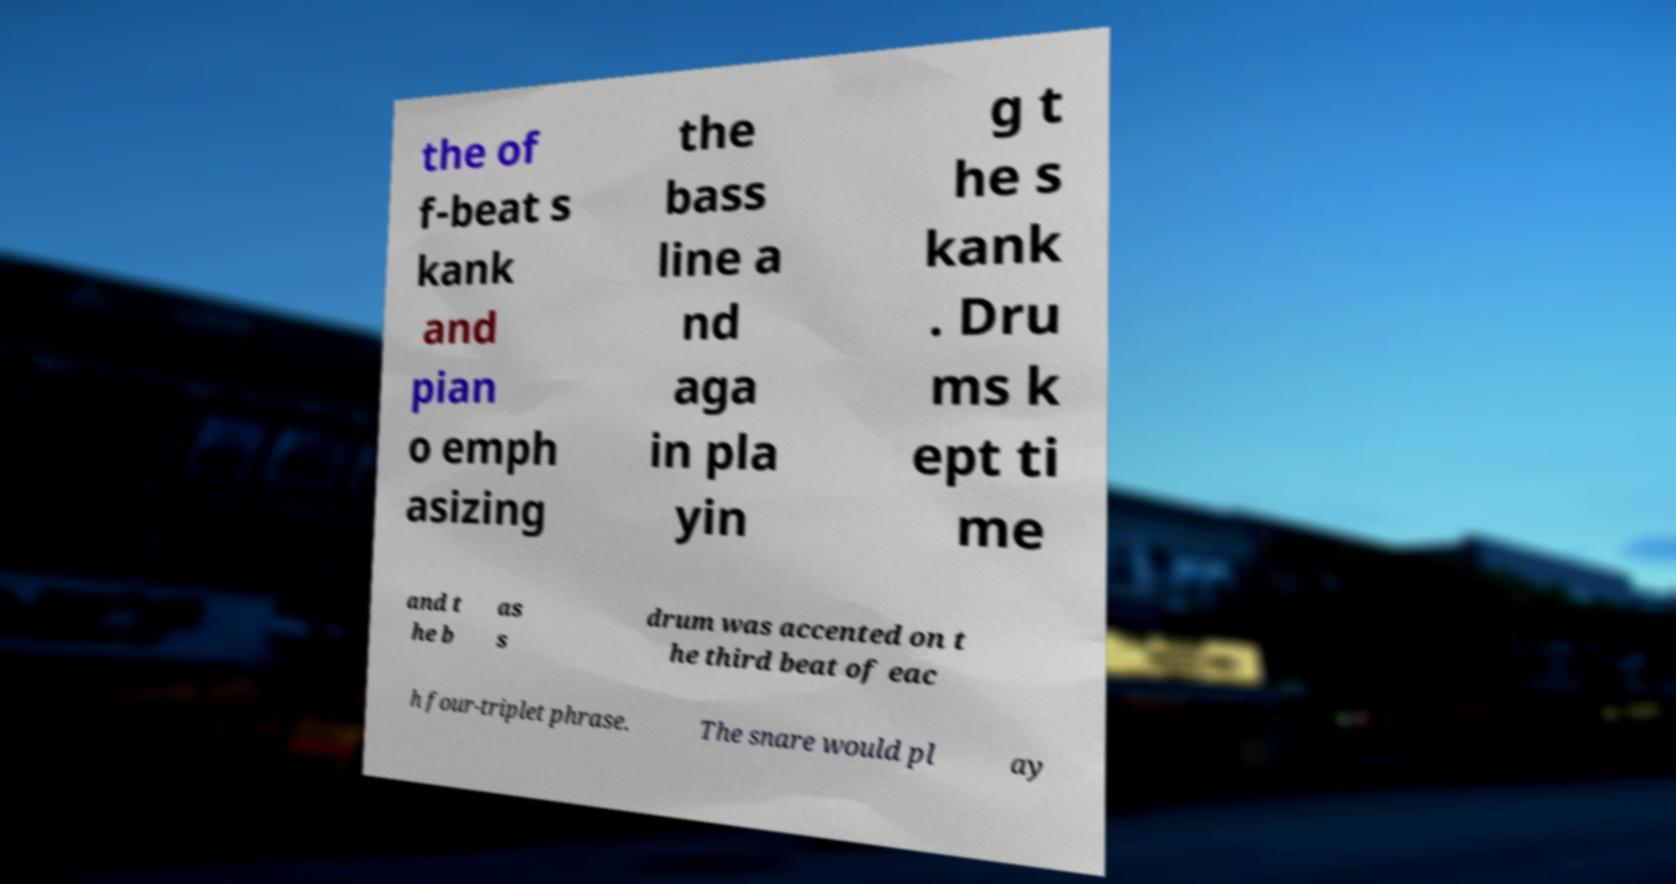Can you accurately transcribe the text from the provided image for me? the of f-beat s kank and pian o emph asizing the bass line a nd aga in pla yin g t he s kank . Dru ms k ept ti me and t he b as s drum was accented on t he third beat of eac h four-triplet phrase. The snare would pl ay 